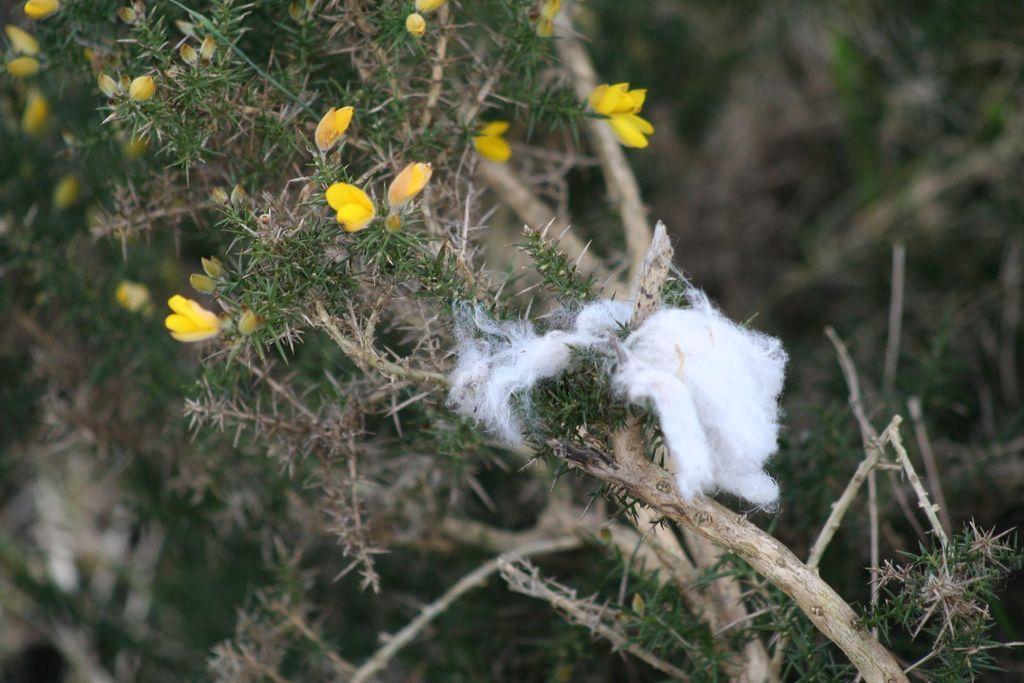What type of flowers can be seen in the image? There are yellow color flowers in the image. What other object is present in the image besides the flowers? There is cotton in the image. Where is the cotton located in the image? The cotton is on a planet. What statement is written on the desk in the image? There is no desk present in the image, so no statement can be written on it. 